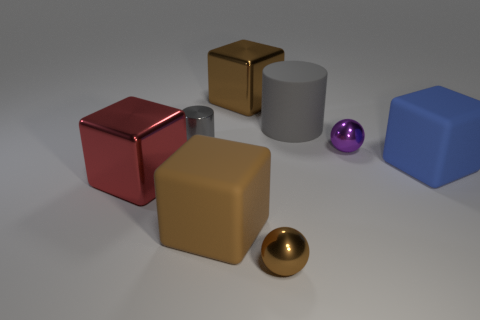What is the material of the big brown block that is on the right side of the brown cube in front of the large blue object?
Your response must be concise. Metal. Is the shape of the purple thing the same as the large blue matte thing?
Offer a very short reply. No. What color is the cylinder that is the same size as the red thing?
Ensure brevity in your answer.  Gray. Are there any metal balls that have the same color as the matte cylinder?
Make the answer very short. No. Is there a purple object?
Keep it short and to the point. Yes. Is the material of the block behind the tiny gray metal cylinder the same as the tiny gray thing?
Offer a terse response. Yes. What is the size of the matte cylinder that is the same color as the small metallic cylinder?
Offer a terse response. Large. What number of green metal blocks are the same size as the red cube?
Offer a terse response. 0. Are there the same number of tiny metal things that are behind the large gray cylinder and big rubber blocks?
Your answer should be very brief. No. What number of small metallic objects are in front of the tiny cylinder and to the left of the large gray thing?
Provide a short and direct response. 1. 